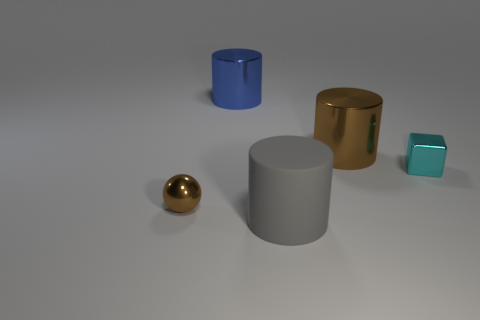There is a big blue cylinder; what number of gray matte things are in front of it?
Your answer should be very brief. 1. What number of other things are the same size as the gray matte object?
Offer a very short reply. 2. There is a brown shiny thing that is the same shape as the gray thing; what size is it?
Keep it short and to the point. Large. There is a big metal object that is behind the brown metallic cylinder; what shape is it?
Offer a very short reply. Cylinder. What is the color of the large metal object right of the blue shiny object behind the tiny cyan metallic thing?
Offer a very short reply. Brown. What number of objects are small metallic objects that are right of the blue cylinder or blue objects?
Make the answer very short. 2. Is the size of the cyan thing the same as the brown metallic object on the left side of the brown shiny cylinder?
Ensure brevity in your answer.  Yes. How many large objects are metallic cubes or brown metal balls?
Provide a short and direct response. 0. The large matte object is what shape?
Your answer should be compact. Cylinder. There is a metallic cylinder that is the same color as the ball; what is its size?
Your answer should be compact. Large. 